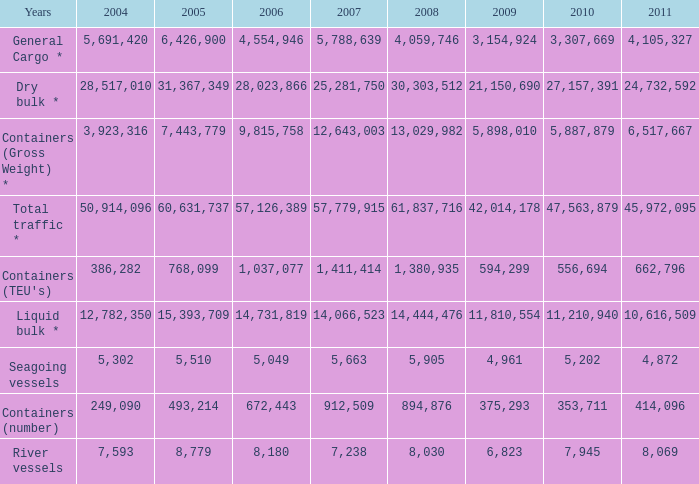What was the total in 2009 for years of river vessels when 2008 was more than 8,030 and 2007 was more than 1,411,414? 0.0. I'm looking to parse the entire table for insights. Could you assist me with that? {'header': ['Years', '2004', '2005', '2006', '2007', '2008', '2009', '2010', '2011'], 'rows': [['General Cargo *', '5,691,420', '6,426,900', '4,554,946', '5,788,639', '4,059,746', '3,154,924', '3,307,669', '4,105,327'], ['Dry bulk *', '28,517,010', '31,367,349', '28,023,866', '25,281,750', '30,303,512', '21,150,690', '27,157,391', '24,732,592'], ['Containers (Gross Weight) *', '3,923,316', '7,443,779', '9,815,758', '12,643,003', '13,029,982', '5,898,010', '5,887,879', '6,517,667'], ['Total traffic *', '50,914,096', '60,631,737', '57,126,389', '57,779,915', '61,837,716', '42,014,178', '47,563,879', '45,972,095'], ["Containers (TEU's)", '386,282', '768,099', '1,037,077', '1,411,414', '1,380,935', '594,299', '556,694', '662,796'], ['Liquid bulk *', '12,782,350', '15,393,709', '14,731,819', '14,066,523', '14,444,476', '11,810,554', '11,210,940', '10,616,509'], ['Seagoing vessels', '5,302', '5,510', '5,049', '5,663', '5,905', '4,961', '5,202', '4,872'], ['Containers (number)', '249,090', '493,214', '672,443', '912,509', '894,876', '375,293', '353,711', '414,096'], ['River vessels', '7,593', '8,779', '8,180', '7,238', '8,030', '6,823', '7,945', '8,069']]} 